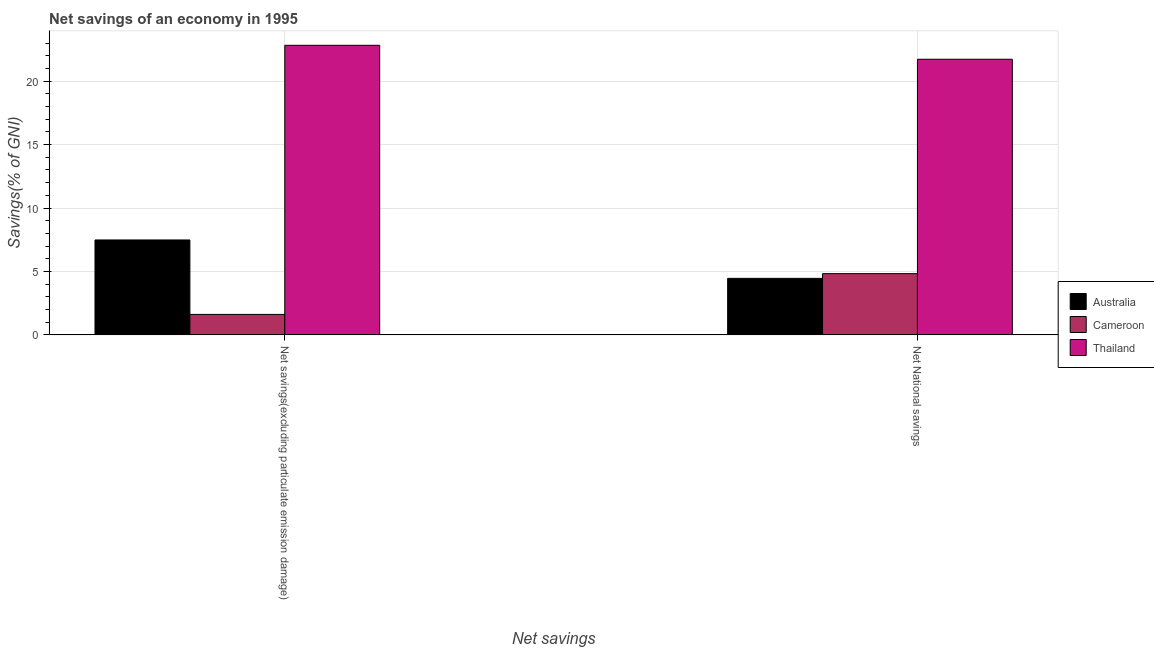Are the number of bars per tick equal to the number of legend labels?
Provide a short and direct response. Yes. Are the number of bars on each tick of the X-axis equal?
Make the answer very short. Yes. How many bars are there on the 1st tick from the left?
Provide a short and direct response. 3. What is the label of the 1st group of bars from the left?
Provide a succinct answer. Net savings(excluding particulate emission damage). What is the net savings(excluding particulate emission damage) in Australia?
Your answer should be compact. 7.48. Across all countries, what is the maximum net national savings?
Your response must be concise. 21.73. Across all countries, what is the minimum net national savings?
Give a very brief answer. 4.46. In which country was the net savings(excluding particulate emission damage) maximum?
Provide a succinct answer. Thailand. What is the total net savings(excluding particulate emission damage) in the graph?
Keep it short and to the point. 31.93. What is the difference between the net savings(excluding particulate emission damage) in Cameroon and that in Australia?
Make the answer very short. -5.87. What is the difference between the net national savings in Australia and the net savings(excluding particulate emission damage) in Thailand?
Give a very brief answer. -18.37. What is the average net savings(excluding particulate emission damage) per country?
Your answer should be very brief. 10.64. What is the difference between the net national savings and net savings(excluding particulate emission damage) in Australia?
Ensure brevity in your answer.  -3.03. What is the ratio of the net national savings in Australia to that in Thailand?
Your answer should be compact. 0.21. What does the 3rd bar from the left in Net savings(excluding particulate emission damage) represents?
Make the answer very short. Thailand. What does the 1st bar from the right in Net National savings represents?
Give a very brief answer. Thailand. Does the graph contain any zero values?
Provide a succinct answer. No. Where does the legend appear in the graph?
Make the answer very short. Center right. How many legend labels are there?
Offer a very short reply. 3. How are the legend labels stacked?
Your answer should be compact. Vertical. What is the title of the graph?
Provide a succinct answer. Net savings of an economy in 1995. What is the label or title of the X-axis?
Your answer should be very brief. Net savings. What is the label or title of the Y-axis?
Give a very brief answer. Savings(% of GNI). What is the Savings(% of GNI) in Australia in Net savings(excluding particulate emission damage)?
Keep it short and to the point. 7.48. What is the Savings(% of GNI) of Cameroon in Net savings(excluding particulate emission damage)?
Offer a terse response. 1.61. What is the Savings(% of GNI) in Thailand in Net savings(excluding particulate emission damage)?
Your response must be concise. 22.83. What is the Savings(% of GNI) of Australia in Net National savings?
Offer a very short reply. 4.46. What is the Savings(% of GNI) in Cameroon in Net National savings?
Make the answer very short. 4.83. What is the Savings(% of GNI) of Thailand in Net National savings?
Keep it short and to the point. 21.73. Across all Net savings, what is the maximum Savings(% of GNI) of Australia?
Provide a succinct answer. 7.48. Across all Net savings, what is the maximum Savings(% of GNI) of Cameroon?
Provide a succinct answer. 4.83. Across all Net savings, what is the maximum Savings(% of GNI) of Thailand?
Ensure brevity in your answer.  22.83. Across all Net savings, what is the minimum Savings(% of GNI) in Australia?
Give a very brief answer. 4.46. Across all Net savings, what is the minimum Savings(% of GNI) in Cameroon?
Keep it short and to the point. 1.61. Across all Net savings, what is the minimum Savings(% of GNI) of Thailand?
Your answer should be compact. 21.73. What is the total Savings(% of GNI) of Australia in the graph?
Give a very brief answer. 11.94. What is the total Savings(% of GNI) of Cameroon in the graph?
Offer a very short reply. 6.44. What is the total Savings(% of GNI) in Thailand in the graph?
Give a very brief answer. 44.56. What is the difference between the Savings(% of GNI) of Australia in Net savings(excluding particulate emission damage) and that in Net National savings?
Your answer should be very brief. 3.03. What is the difference between the Savings(% of GNI) of Cameroon in Net savings(excluding particulate emission damage) and that in Net National savings?
Offer a terse response. -3.21. What is the difference between the Savings(% of GNI) in Thailand in Net savings(excluding particulate emission damage) and that in Net National savings?
Make the answer very short. 1.1. What is the difference between the Savings(% of GNI) in Australia in Net savings(excluding particulate emission damage) and the Savings(% of GNI) in Cameroon in Net National savings?
Give a very brief answer. 2.66. What is the difference between the Savings(% of GNI) in Australia in Net savings(excluding particulate emission damage) and the Savings(% of GNI) in Thailand in Net National savings?
Offer a very short reply. -14.25. What is the difference between the Savings(% of GNI) of Cameroon in Net savings(excluding particulate emission damage) and the Savings(% of GNI) of Thailand in Net National savings?
Ensure brevity in your answer.  -20.12. What is the average Savings(% of GNI) in Australia per Net savings?
Offer a very short reply. 5.97. What is the average Savings(% of GNI) of Cameroon per Net savings?
Provide a short and direct response. 3.22. What is the average Savings(% of GNI) of Thailand per Net savings?
Keep it short and to the point. 22.28. What is the difference between the Savings(% of GNI) in Australia and Savings(% of GNI) in Cameroon in Net savings(excluding particulate emission damage)?
Ensure brevity in your answer.  5.87. What is the difference between the Savings(% of GNI) in Australia and Savings(% of GNI) in Thailand in Net savings(excluding particulate emission damage)?
Offer a very short reply. -15.35. What is the difference between the Savings(% of GNI) in Cameroon and Savings(% of GNI) in Thailand in Net savings(excluding particulate emission damage)?
Your response must be concise. -21.21. What is the difference between the Savings(% of GNI) of Australia and Savings(% of GNI) of Cameroon in Net National savings?
Provide a succinct answer. -0.37. What is the difference between the Savings(% of GNI) of Australia and Savings(% of GNI) of Thailand in Net National savings?
Offer a very short reply. -17.27. What is the difference between the Savings(% of GNI) of Cameroon and Savings(% of GNI) of Thailand in Net National savings?
Keep it short and to the point. -16.9. What is the ratio of the Savings(% of GNI) in Australia in Net savings(excluding particulate emission damage) to that in Net National savings?
Keep it short and to the point. 1.68. What is the ratio of the Savings(% of GNI) of Cameroon in Net savings(excluding particulate emission damage) to that in Net National savings?
Offer a very short reply. 0.33. What is the ratio of the Savings(% of GNI) of Thailand in Net savings(excluding particulate emission damage) to that in Net National savings?
Offer a very short reply. 1.05. What is the difference between the highest and the second highest Savings(% of GNI) of Australia?
Offer a terse response. 3.03. What is the difference between the highest and the second highest Savings(% of GNI) of Cameroon?
Provide a succinct answer. 3.21. What is the difference between the highest and the second highest Savings(% of GNI) of Thailand?
Give a very brief answer. 1.1. What is the difference between the highest and the lowest Savings(% of GNI) of Australia?
Offer a very short reply. 3.03. What is the difference between the highest and the lowest Savings(% of GNI) in Cameroon?
Ensure brevity in your answer.  3.21. What is the difference between the highest and the lowest Savings(% of GNI) of Thailand?
Keep it short and to the point. 1.1. 